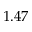<formula> <loc_0><loc_0><loc_500><loc_500>1 . 4 7</formula> 